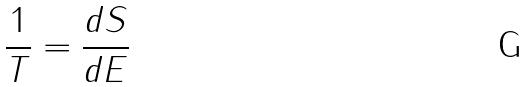Convert formula to latex. <formula><loc_0><loc_0><loc_500><loc_500>\frac { 1 } { T } = \frac { d S } { d E }</formula> 